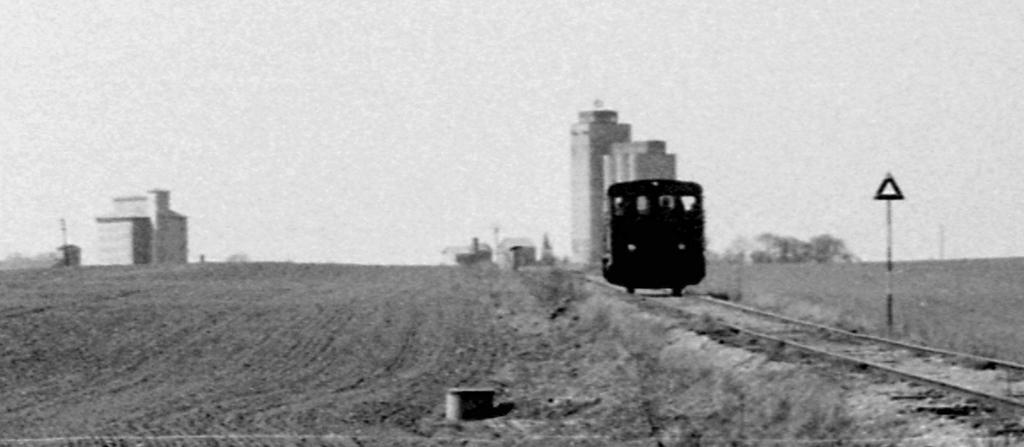What is the color scheme of the image? The image is black and white and white. What is the main subject in the image? There is a train in the middle of the image. Where is the train located in relation to the track? The train is on a track. What can be seen in the background of the image? There are buildings in the background of the image. What is visible above the train? The sky is visible above the train. How many letters can be seen on the lizards in the image? There are no lizards present in the image, so there are no letters on them. Can you confirm the existence of the train's existence in the image? The train's existence is already confirmed in the image, as it is mentioned as the main subject. 